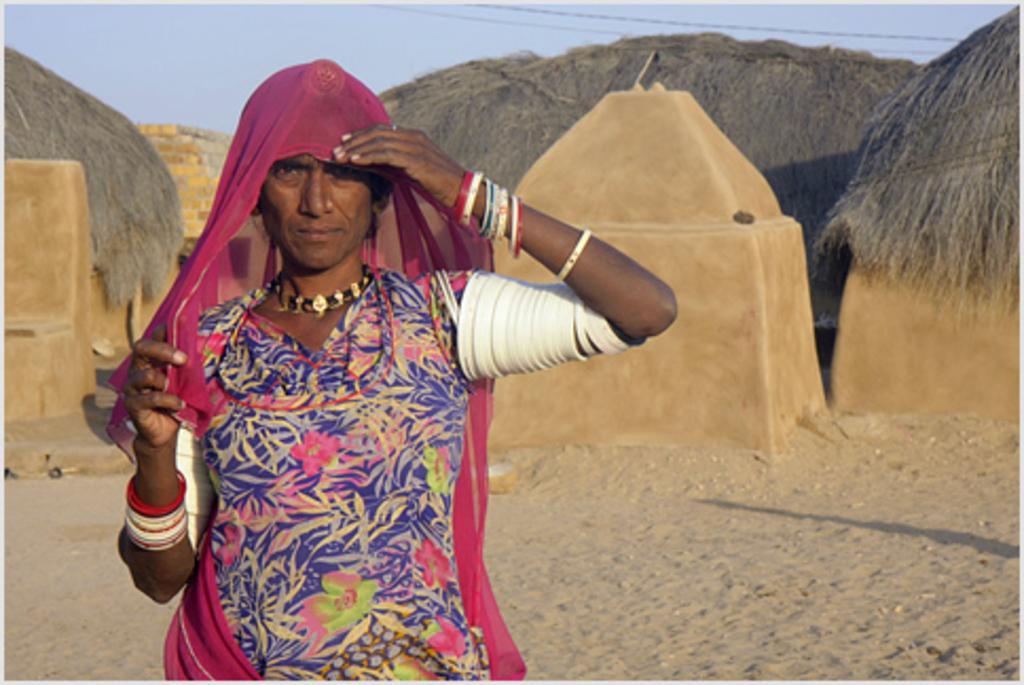What is the main subject of the image? There is a person standing in the image. Where is the person standing? The person is standing on the ground. What can be seen in the background of the image? There are sheds and the sky visible in the background of the image. How many eggs are being cared for in the downtown area in the image? There is no reference to eggs, care, or downtown in the image, so it is not possible to answer that question. 